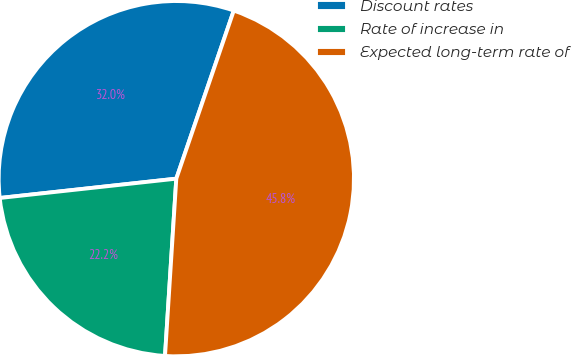<chart> <loc_0><loc_0><loc_500><loc_500><pie_chart><fcel>Discount rates<fcel>Rate of increase in<fcel>Expected long-term rate of<nl><fcel>31.98%<fcel>22.25%<fcel>45.77%<nl></chart> 